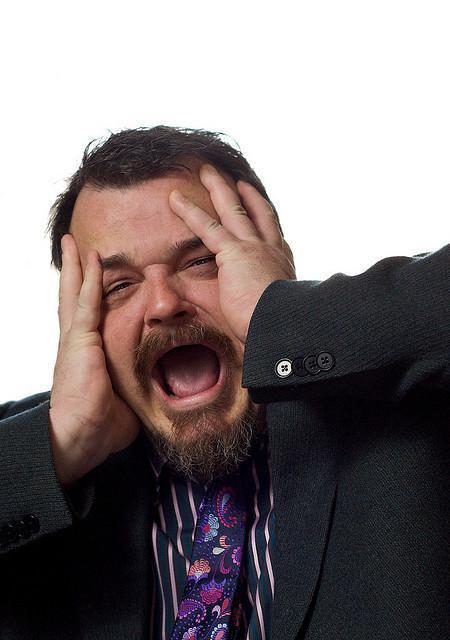How many cows are in the picture?
Give a very brief answer. 0. 